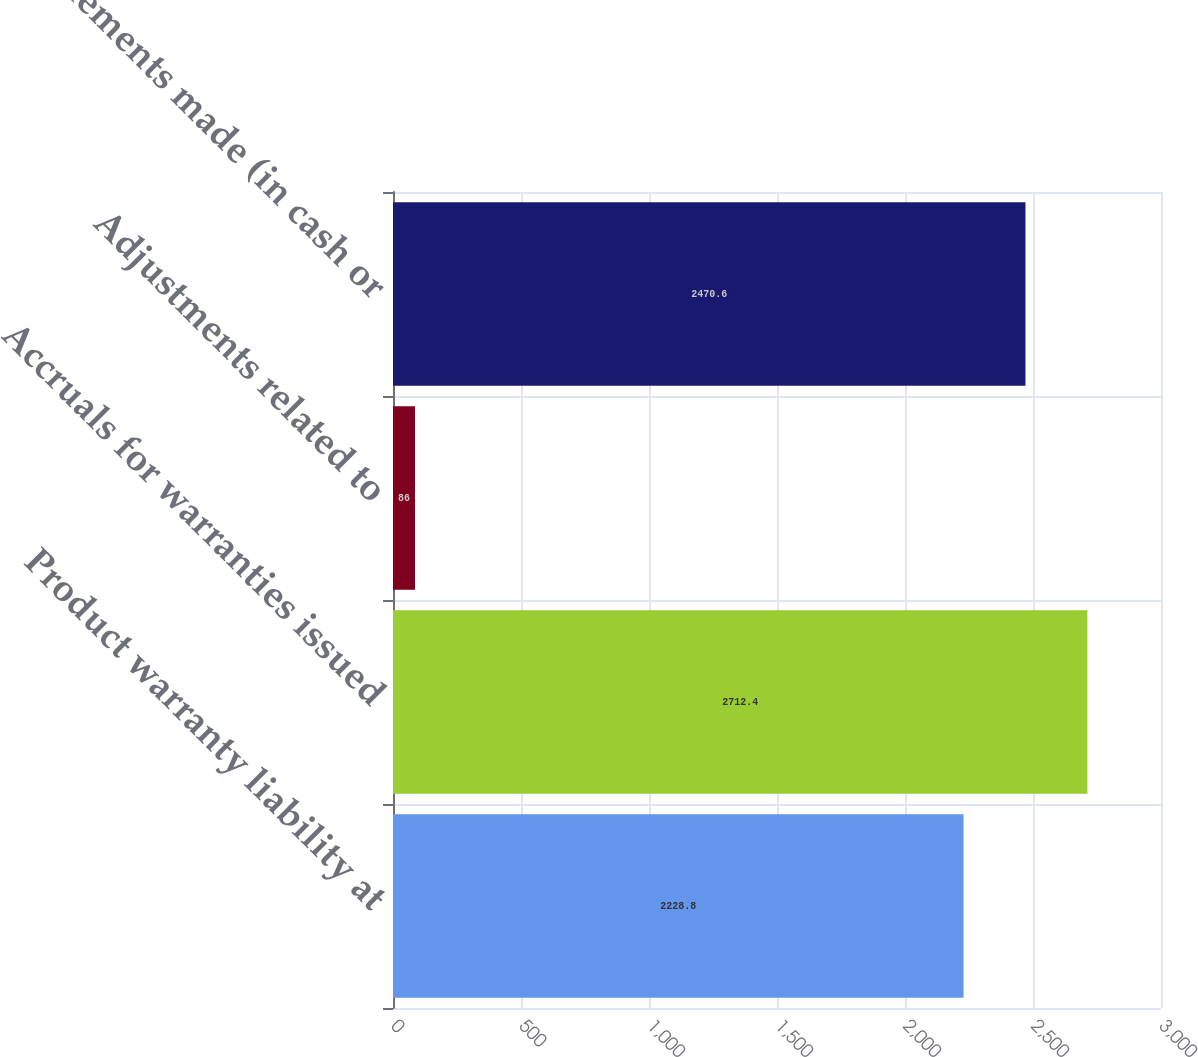Convert chart. <chart><loc_0><loc_0><loc_500><loc_500><bar_chart><fcel>Product warranty liability at<fcel>Accruals for warranties issued<fcel>Adjustments related to<fcel>Settlements made (in cash or<nl><fcel>2228.8<fcel>2712.4<fcel>86<fcel>2470.6<nl></chart> 